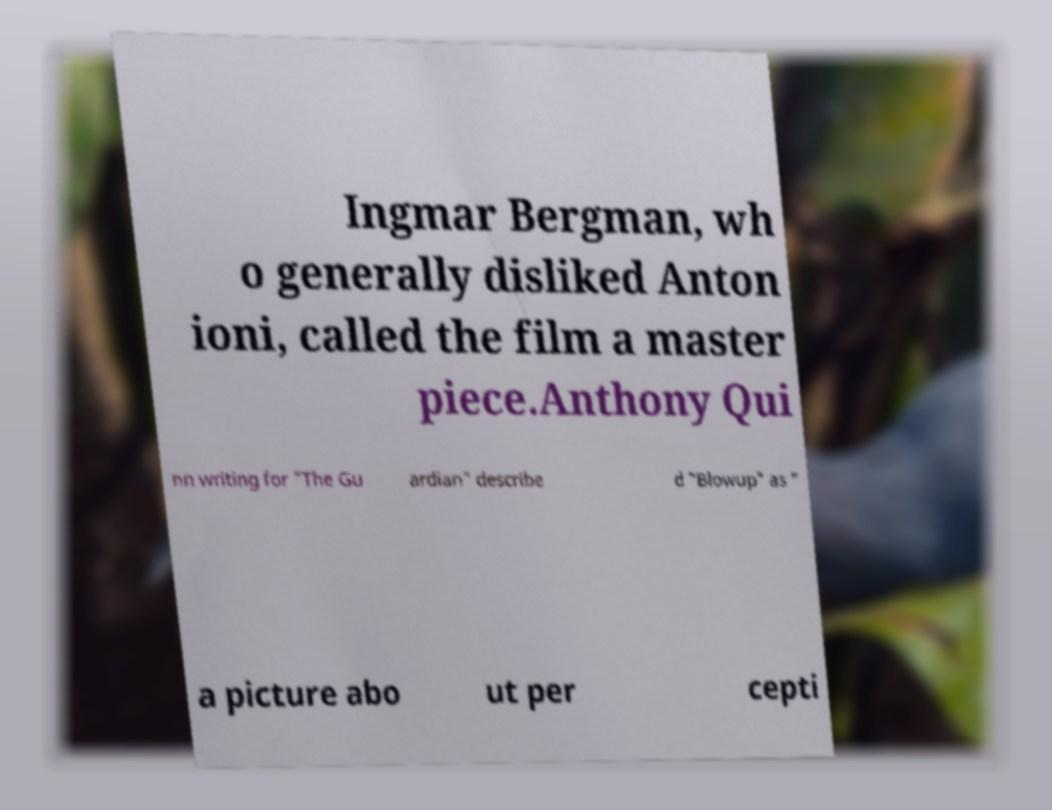Could you assist in decoding the text presented in this image and type it out clearly? Ingmar Bergman, wh o generally disliked Anton ioni, called the film a master piece.Anthony Qui nn writing for "The Gu ardian" describe d "Blowup" as " a picture abo ut per cepti 